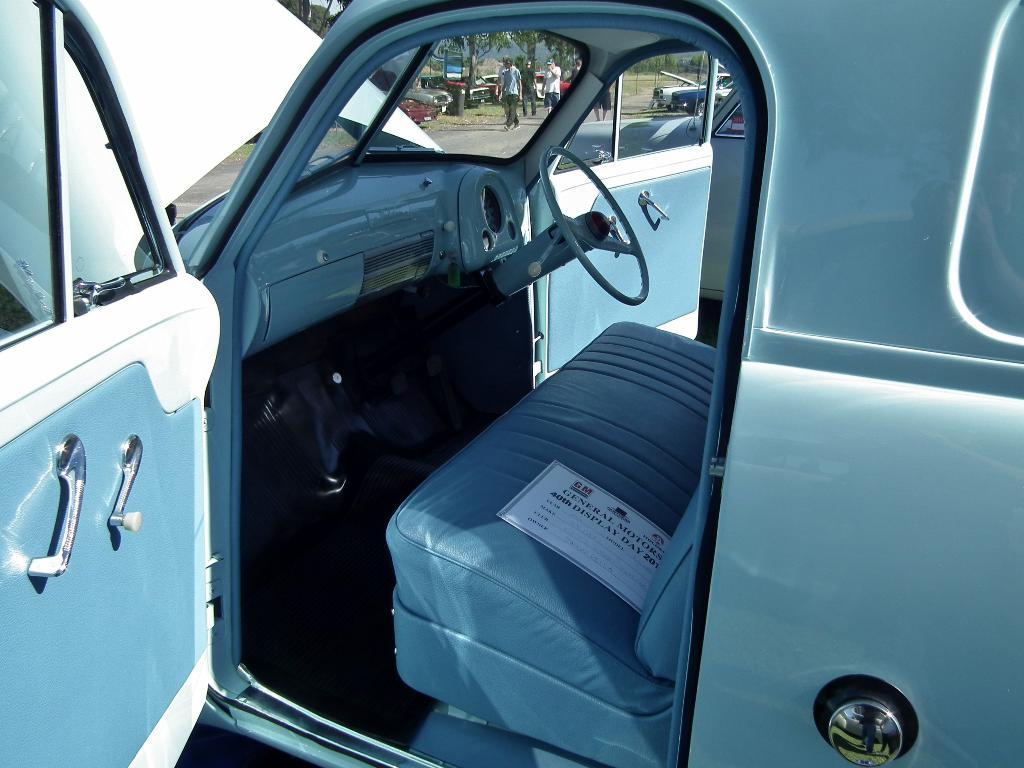What color is the vehicle in the image? The vehicle in the image is blue. What else can be seen in the background of the image? There are other vehicles and people walking in the background of the image. What type of vegetation is present in the background of the image? There are trees with green color in the background of the image. What type of fruit is hanging from the trees in the image? There is no fruit hanging from the trees in the image; only the green color of the trees is mentioned. 